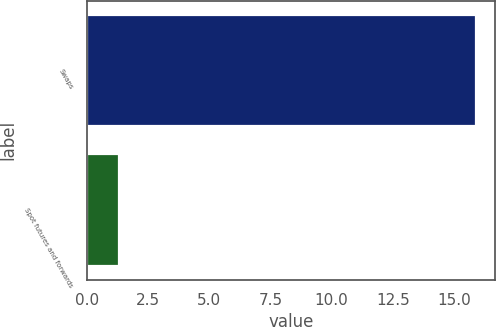<chart> <loc_0><loc_0><loc_500><loc_500><bar_chart><fcel>Swaps<fcel>Spot futures and forwards<nl><fcel>15.9<fcel>1.3<nl></chart> 